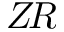Convert formula to latex. <formula><loc_0><loc_0><loc_500><loc_500>Z \, R</formula> 